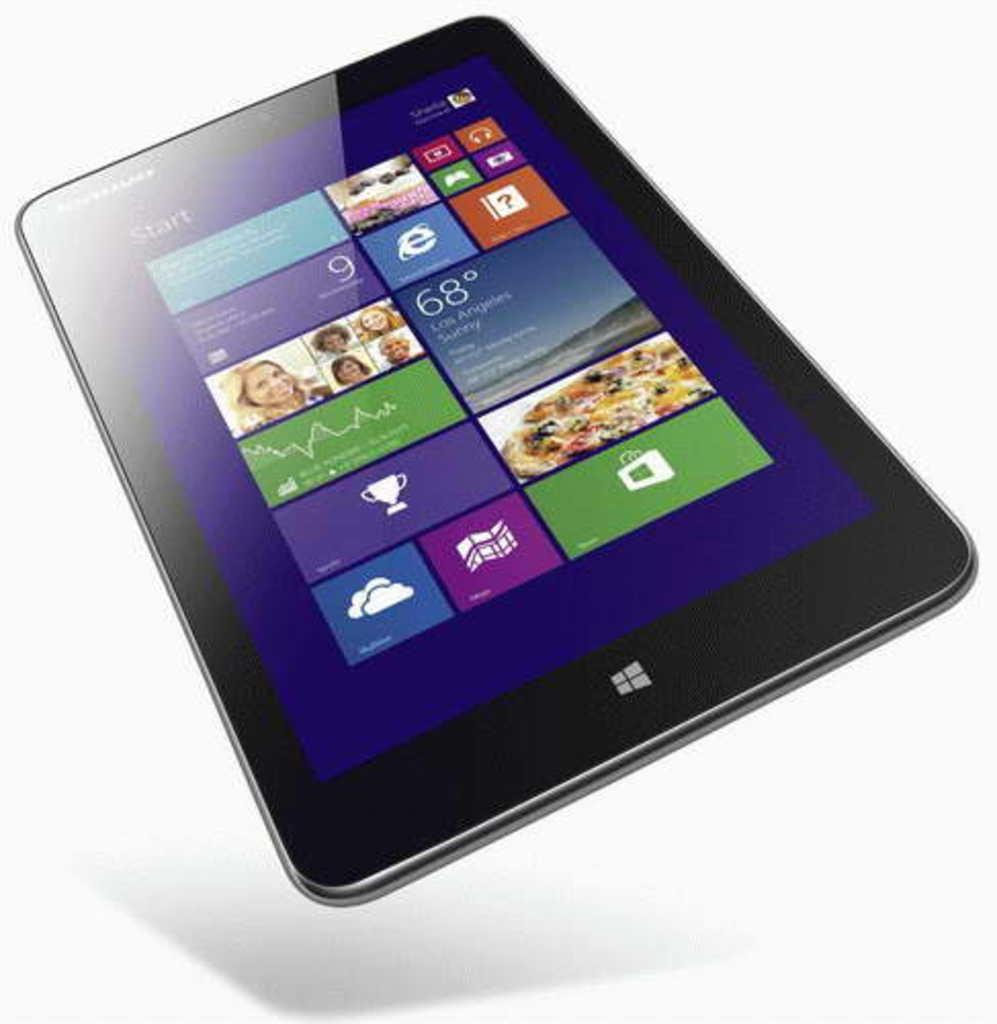What electronic device is visible in the image? There is a tablet in the image. What can be seen on the screen of the tablet? There are pictures of people, text, and other things on the display of the tablet. What is the color of the background in the image? The background of the image is white in color. What type of grass is growing on the tablet in the image? There is no grass present on the tablet in the image. Is the doll visible in the image? There is no doll present in the image. 